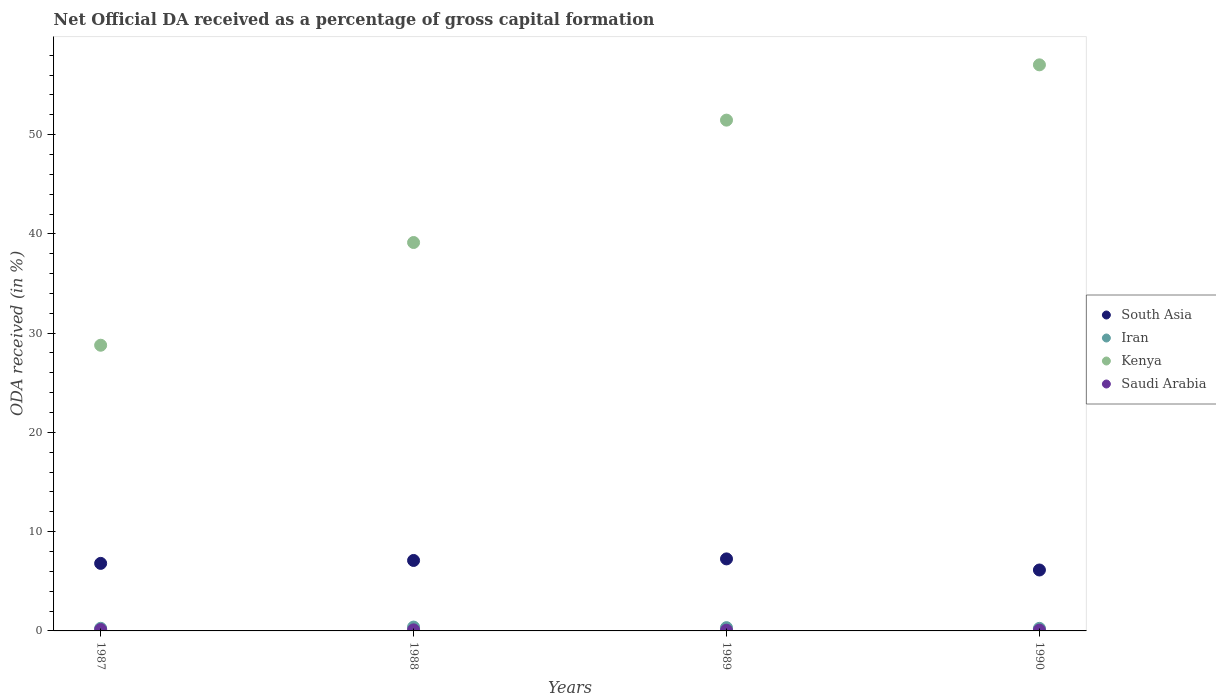How many different coloured dotlines are there?
Offer a very short reply. 4. What is the net ODA received in South Asia in 1988?
Your response must be concise. 7.1. Across all years, what is the maximum net ODA received in Saudi Arabia?
Your answer should be compact. 0.14. Across all years, what is the minimum net ODA received in Saudi Arabia?
Ensure brevity in your answer.  0.07. In which year was the net ODA received in Saudi Arabia minimum?
Your answer should be very brief. 1989. What is the total net ODA received in Kenya in the graph?
Offer a terse response. 176.4. What is the difference between the net ODA received in Saudi Arabia in 1989 and that in 1990?
Give a very brief answer. -0.01. What is the difference between the net ODA received in Iran in 1988 and the net ODA received in South Asia in 1987?
Your response must be concise. -6.42. What is the average net ODA received in Kenya per year?
Make the answer very short. 44.1. In the year 1989, what is the difference between the net ODA received in Iran and net ODA received in Kenya?
Offer a very short reply. -51.13. What is the ratio of the net ODA received in South Asia in 1987 to that in 1989?
Offer a terse response. 0.94. Is the difference between the net ODA received in Iran in 1988 and 1989 greater than the difference between the net ODA received in Kenya in 1988 and 1989?
Make the answer very short. Yes. What is the difference between the highest and the second highest net ODA received in Iran?
Your answer should be very brief. 0.06. What is the difference between the highest and the lowest net ODA received in Iran?
Provide a succinct answer. 0.13. Is the net ODA received in Saudi Arabia strictly greater than the net ODA received in South Asia over the years?
Give a very brief answer. No. How many dotlines are there?
Offer a very short reply. 4. How many years are there in the graph?
Make the answer very short. 4. Are the values on the major ticks of Y-axis written in scientific E-notation?
Offer a very short reply. No. Does the graph contain grids?
Provide a succinct answer. No. Where does the legend appear in the graph?
Give a very brief answer. Center right. How many legend labels are there?
Your answer should be compact. 4. How are the legend labels stacked?
Give a very brief answer. Vertical. What is the title of the graph?
Keep it short and to the point. Net Official DA received as a percentage of gross capital formation. Does "Tonga" appear as one of the legend labels in the graph?
Ensure brevity in your answer.  No. What is the label or title of the X-axis?
Provide a short and direct response. Years. What is the label or title of the Y-axis?
Give a very brief answer. ODA received (in %). What is the ODA received (in %) in South Asia in 1987?
Offer a very short reply. 6.8. What is the ODA received (in %) in Iran in 1987?
Your answer should be very brief. 0.26. What is the ODA received (in %) in Kenya in 1987?
Provide a short and direct response. 28.78. What is the ODA received (in %) of Saudi Arabia in 1987?
Your response must be concise. 0.14. What is the ODA received (in %) in South Asia in 1988?
Your answer should be compact. 7.1. What is the ODA received (in %) in Iran in 1988?
Your answer should be very brief. 0.39. What is the ODA received (in %) of Kenya in 1988?
Offer a very short reply. 39.13. What is the ODA received (in %) in Saudi Arabia in 1988?
Offer a very short reply. 0.11. What is the ODA received (in %) in South Asia in 1989?
Your answer should be very brief. 7.26. What is the ODA received (in %) of Iran in 1989?
Give a very brief answer. 0.33. What is the ODA received (in %) in Kenya in 1989?
Make the answer very short. 51.46. What is the ODA received (in %) in Saudi Arabia in 1989?
Your answer should be very brief. 0.07. What is the ODA received (in %) in South Asia in 1990?
Give a very brief answer. 6.14. What is the ODA received (in %) in Iran in 1990?
Provide a succinct answer. 0.26. What is the ODA received (in %) of Kenya in 1990?
Provide a succinct answer. 57.03. What is the ODA received (in %) in Saudi Arabia in 1990?
Make the answer very short. 0.08. Across all years, what is the maximum ODA received (in %) of South Asia?
Your answer should be compact. 7.26. Across all years, what is the maximum ODA received (in %) in Iran?
Your answer should be compact. 0.39. Across all years, what is the maximum ODA received (in %) of Kenya?
Offer a terse response. 57.03. Across all years, what is the maximum ODA received (in %) in Saudi Arabia?
Your answer should be very brief. 0.14. Across all years, what is the minimum ODA received (in %) of South Asia?
Make the answer very short. 6.14. Across all years, what is the minimum ODA received (in %) in Iran?
Offer a very short reply. 0.26. Across all years, what is the minimum ODA received (in %) in Kenya?
Give a very brief answer. 28.78. Across all years, what is the minimum ODA received (in %) of Saudi Arabia?
Give a very brief answer. 0.07. What is the total ODA received (in %) of South Asia in the graph?
Offer a terse response. 27.3. What is the total ODA received (in %) in Iran in the graph?
Make the answer very short. 1.24. What is the total ODA received (in %) in Kenya in the graph?
Your response must be concise. 176.4. What is the total ODA received (in %) of Saudi Arabia in the graph?
Your response must be concise. 0.4. What is the difference between the ODA received (in %) of South Asia in 1987 and that in 1988?
Your response must be concise. -0.29. What is the difference between the ODA received (in %) in Iran in 1987 and that in 1988?
Give a very brief answer. -0.12. What is the difference between the ODA received (in %) in Kenya in 1987 and that in 1988?
Offer a very short reply. -10.35. What is the difference between the ODA received (in %) of Saudi Arabia in 1987 and that in 1988?
Ensure brevity in your answer.  0.03. What is the difference between the ODA received (in %) of South Asia in 1987 and that in 1989?
Your answer should be very brief. -0.45. What is the difference between the ODA received (in %) of Iran in 1987 and that in 1989?
Provide a succinct answer. -0.07. What is the difference between the ODA received (in %) of Kenya in 1987 and that in 1989?
Provide a succinct answer. -22.68. What is the difference between the ODA received (in %) of Saudi Arabia in 1987 and that in 1989?
Offer a terse response. 0.07. What is the difference between the ODA received (in %) of South Asia in 1987 and that in 1990?
Offer a very short reply. 0.67. What is the difference between the ODA received (in %) of Iran in 1987 and that in 1990?
Keep it short and to the point. 0.01. What is the difference between the ODA received (in %) of Kenya in 1987 and that in 1990?
Offer a very short reply. -28.25. What is the difference between the ODA received (in %) in Saudi Arabia in 1987 and that in 1990?
Provide a short and direct response. 0.06. What is the difference between the ODA received (in %) in South Asia in 1988 and that in 1989?
Provide a succinct answer. -0.16. What is the difference between the ODA received (in %) of Iran in 1988 and that in 1989?
Give a very brief answer. 0.06. What is the difference between the ODA received (in %) of Kenya in 1988 and that in 1989?
Your answer should be compact. -12.33. What is the difference between the ODA received (in %) of Saudi Arabia in 1988 and that in 1989?
Give a very brief answer. 0.03. What is the difference between the ODA received (in %) in South Asia in 1988 and that in 1990?
Provide a short and direct response. 0.96. What is the difference between the ODA received (in %) in Iran in 1988 and that in 1990?
Give a very brief answer. 0.13. What is the difference between the ODA received (in %) of Kenya in 1988 and that in 1990?
Your response must be concise. -17.9. What is the difference between the ODA received (in %) of Saudi Arabia in 1988 and that in 1990?
Your answer should be very brief. 0.02. What is the difference between the ODA received (in %) in South Asia in 1989 and that in 1990?
Make the answer very short. 1.12. What is the difference between the ODA received (in %) in Iran in 1989 and that in 1990?
Provide a short and direct response. 0.07. What is the difference between the ODA received (in %) in Kenya in 1989 and that in 1990?
Ensure brevity in your answer.  -5.57. What is the difference between the ODA received (in %) of Saudi Arabia in 1989 and that in 1990?
Provide a short and direct response. -0.01. What is the difference between the ODA received (in %) of South Asia in 1987 and the ODA received (in %) of Iran in 1988?
Your answer should be compact. 6.42. What is the difference between the ODA received (in %) of South Asia in 1987 and the ODA received (in %) of Kenya in 1988?
Give a very brief answer. -32.33. What is the difference between the ODA received (in %) in South Asia in 1987 and the ODA received (in %) in Saudi Arabia in 1988?
Provide a short and direct response. 6.7. What is the difference between the ODA received (in %) in Iran in 1987 and the ODA received (in %) in Kenya in 1988?
Give a very brief answer. -38.87. What is the difference between the ODA received (in %) of Iran in 1987 and the ODA received (in %) of Saudi Arabia in 1988?
Ensure brevity in your answer.  0.16. What is the difference between the ODA received (in %) in Kenya in 1987 and the ODA received (in %) in Saudi Arabia in 1988?
Give a very brief answer. 28.67. What is the difference between the ODA received (in %) in South Asia in 1987 and the ODA received (in %) in Iran in 1989?
Keep it short and to the point. 6.47. What is the difference between the ODA received (in %) of South Asia in 1987 and the ODA received (in %) of Kenya in 1989?
Your response must be concise. -44.65. What is the difference between the ODA received (in %) of South Asia in 1987 and the ODA received (in %) of Saudi Arabia in 1989?
Your answer should be very brief. 6.73. What is the difference between the ODA received (in %) in Iran in 1987 and the ODA received (in %) in Kenya in 1989?
Give a very brief answer. -51.19. What is the difference between the ODA received (in %) of Iran in 1987 and the ODA received (in %) of Saudi Arabia in 1989?
Provide a succinct answer. 0.19. What is the difference between the ODA received (in %) in Kenya in 1987 and the ODA received (in %) in Saudi Arabia in 1989?
Offer a very short reply. 28.71. What is the difference between the ODA received (in %) of South Asia in 1987 and the ODA received (in %) of Iran in 1990?
Provide a succinct answer. 6.55. What is the difference between the ODA received (in %) in South Asia in 1987 and the ODA received (in %) in Kenya in 1990?
Make the answer very short. -50.22. What is the difference between the ODA received (in %) of South Asia in 1987 and the ODA received (in %) of Saudi Arabia in 1990?
Offer a terse response. 6.72. What is the difference between the ODA received (in %) of Iran in 1987 and the ODA received (in %) of Kenya in 1990?
Your response must be concise. -56.76. What is the difference between the ODA received (in %) in Iran in 1987 and the ODA received (in %) in Saudi Arabia in 1990?
Your answer should be compact. 0.18. What is the difference between the ODA received (in %) in Kenya in 1987 and the ODA received (in %) in Saudi Arabia in 1990?
Give a very brief answer. 28.7. What is the difference between the ODA received (in %) in South Asia in 1988 and the ODA received (in %) in Iran in 1989?
Provide a short and direct response. 6.77. What is the difference between the ODA received (in %) of South Asia in 1988 and the ODA received (in %) of Kenya in 1989?
Offer a very short reply. -44.36. What is the difference between the ODA received (in %) in South Asia in 1988 and the ODA received (in %) in Saudi Arabia in 1989?
Your answer should be compact. 7.02. What is the difference between the ODA received (in %) in Iran in 1988 and the ODA received (in %) in Kenya in 1989?
Provide a short and direct response. -51.07. What is the difference between the ODA received (in %) of Iran in 1988 and the ODA received (in %) of Saudi Arabia in 1989?
Give a very brief answer. 0.31. What is the difference between the ODA received (in %) of Kenya in 1988 and the ODA received (in %) of Saudi Arabia in 1989?
Your response must be concise. 39.06. What is the difference between the ODA received (in %) in South Asia in 1988 and the ODA received (in %) in Iran in 1990?
Ensure brevity in your answer.  6.84. What is the difference between the ODA received (in %) in South Asia in 1988 and the ODA received (in %) in Kenya in 1990?
Ensure brevity in your answer.  -49.93. What is the difference between the ODA received (in %) in South Asia in 1988 and the ODA received (in %) in Saudi Arabia in 1990?
Your response must be concise. 7.01. What is the difference between the ODA received (in %) of Iran in 1988 and the ODA received (in %) of Kenya in 1990?
Ensure brevity in your answer.  -56.64. What is the difference between the ODA received (in %) in Iran in 1988 and the ODA received (in %) in Saudi Arabia in 1990?
Your answer should be very brief. 0.3. What is the difference between the ODA received (in %) in Kenya in 1988 and the ODA received (in %) in Saudi Arabia in 1990?
Provide a short and direct response. 39.05. What is the difference between the ODA received (in %) in South Asia in 1989 and the ODA received (in %) in Iran in 1990?
Provide a short and direct response. 7. What is the difference between the ODA received (in %) in South Asia in 1989 and the ODA received (in %) in Kenya in 1990?
Your answer should be very brief. -49.77. What is the difference between the ODA received (in %) of South Asia in 1989 and the ODA received (in %) of Saudi Arabia in 1990?
Give a very brief answer. 7.17. What is the difference between the ODA received (in %) in Iran in 1989 and the ODA received (in %) in Kenya in 1990?
Provide a succinct answer. -56.7. What is the difference between the ODA received (in %) in Iran in 1989 and the ODA received (in %) in Saudi Arabia in 1990?
Your answer should be very brief. 0.25. What is the difference between the ODA received (in %) of Kenya in 1989 and the ODA received (in %) of Saudi Arabia in 1990?
Your answer should be compact. 51.37. What is the average ODA received (in %) in South Asia per year?
Your response must be concise. 6.82. What is the average ODA received (in %) in Iran per year?
Keep it short and to the point. 0.31. What is the average ODA received (in %) in Kenya per year?
Give a very brief answer. 44.1. What is the average ODA received (in %) in Saudi Arabia per year?
Make the answer very short. 0.1. In the year 1987, what is the difference between the ODA received (in %) of South Asia and ODA received (in %) of Iran?
Make the answer very short. 6.54. In the year 1987, what is the difference between the ODA received (in %) of South Asia and ODA received (in %) of Kenya?
Offer a very short reply. -21.98. In the year 1987, what is the difference between the ODA received (in %) in South Asia and ODA received (in %) in Saudi Arabia?
Give a very brief answer. 6.66. In the year 1987, what is the difference between the ODA received (in %) in Iran and ODA received (in %) in Kenya?
Provide a succinct answer. -28.52. In the year 1987, what is the difference between the ODA received (in %) in Iran and ODA received (in %) in Saudi Arabia?
Make the answer very short. 0.12. In the year 1987, what is the difference between the ODA received (in %) in Kenya and ODA received (in %) in Saudi Arabia?
Your answer should be compact. 28.64. In the year 1988, what is the difference between the ODA received (in %) in South Asia and ODA received (in %) in Iran?
Keep it short and to the point. 6.71. In the year 1988, what is the difference between the ODA received (in %) of South Asia and ODA received (in %) of Kenya?
Provide a short and direct response. -32.03. In the year 1988, what is the difference between the ODA received (in %) in South Asia and ODA received (in %) in Saudi Arabia?
Your response must be concise. 6.99. In the year 1988, what is the difference between the ODA received (in %) in Iran and ODA received (in %) in Kenya?
Ensure brevity in your answer.  -38.74. In the year 1988, what is the difference between the ODA received (in %) of Iran and ODA received (in %) of Saudi Arabia?
Make the answer very short. 0.28. In the year 1988, what is the difference between the ODA received (in %) in Kenya and ODA received (in %) in Saudi Arabia?
Your answer should be very brief. 39.02. In the year 1989, what is the difference between the ODA received (in %) of South Asia and ODA received (in %) of Iran?
Provide a succinct answer. 6.93. In the year 1989, what is the difference between the ODA received (in %) of South Asia and ODA received (in %) of Kenya?
Make the answer very short. -44.2. In the year 1989, what is the difference between the ODA received (in %) of South Asia and ODA received (in %) of Saudi Arabia?
Provide a succinct answer. 7.18. In the year 1989, what is the difference between the ODA received (in %) of Iran and ODA received (in %) of Kenya?
Provide a short and direct response. -51.13. In the year 1989, what is the difference between the ODA received (in %) of Iran and ODA received (in %) of Saudi Arabia?
Provide a succinct answer. 0.26. In the year 1989, what is the difference between the ODA received (in %) of Kenya and ODA received (in %) of Saudi Arabia?
Keep it short and to the point. 51.38. In the year 1990, what is the difference between the ODA received (in %) of South Asia and ODA received (in %) of Iran?
Your answer should be compact. 5.88. In the year 1990, what is the difference between the ODA received (in %) in South Asia and ODA received (in %) in Kenya?
Give a very brief answer. -50.89. In the year 1990, what is the difference between the ODA received (in %) in South Asia and ODA received (in %) in Saudi Arabia?
Offer a very short reply. 6.05. In the year 1990, what is the difference between the ODA received (in %) in Iran and ODA received (in %) in Kenya?
Provide a succinct answer. -56.77. In the year 1990, what is the difference between the ODA received (in %) of Iran and ODA received (in %) of Saudi Arabia?
Ensure brevity in your answer.  0.17. In the year 1990, what is the difference between the ODA received (in %) in Kenya and ODA received (in %) in Saudi Arabia?
Your answer should be very brief. 56.94. What is the ratio of the ODA received (in %) in South Asia in 1987 to that in 1988?
Your answer should be very brief. 0.96. What is the ratio of the ODA received (in %) of Iran in 1987 to that in 1988?
Offer a terse response. 0.68. What is the ratio of the ODA received (in %) in Kenya in 1987 to that in 1988?
Keep it short and to the point. 0.74. What is the ratio of the ODA received (in %) of Saudi Arabia in 1987 to that in 1988?
Make the answer very short. 1.3. What is the ratio of the ODA received (in %) of South Asia in 1987 to that in 1989?
Your response must be concise. 0.94. What is the ratio of the ODA received (in %) of Iran in 1987 to that in 1989?
Your answer should be compact. 0.8. What is the ratio of the ODA received (in %) in Kenya in 1987 to that in 1989?
Provide a succinct answer. 0.56. What is the ratio of the ODA received (in %) of Saudi Arabia in 1987 to that in 1989?
Offer a terse response. 1.91. What is the ratio of the ODA received (in %) of South Asia in 1987 to that in 1990?
Make the answer very short. 1.11. What is the ratio of the ODA received (in %) in Iran in 1987 to that in 1990?
Offer a very short reply. 1.02. What is the ratio of the ODA received (in %) in Kenya in 1987 to that in 1990?
Your answer should be compact. 0.5. What is the ratio of the ODA received (in %) of Saudi Arabia in 1987 to that in 1990?
Ensure brevity in your answer.  1.69. What is the ratio of the ODA received (in %) in South Asia in 1988 to that in 1989?
Your response must be concise. 0.98. What is the ratio of the ODA received (in %) in Iran in 1988 to that in 1989?
Your answer should be very brief. 1.17. What is the ratio of the ODA received (in %) of Kenya in 1988 to that in 1989?
Provide a short and direct response. 0.76. What is the ratio of the ODA received (in %) of Saudi Arabia in 1988 to that in 1989?
Your answer should be very brief. 1.47. What is the ratio of the ODA received (in %) of South Asia in 1988 to that in 1990?
Provide a succinct answer. 1.16. What is the ratio of the ODA received (in %) of Iran in 1988 to that in 1990?
Ensure brevity in your answer.  1.49. What is the ratio of the ODA received (in %) of Kenya in 1988 to that in 1990?
Offer a terse response. 0.69. What is the ratio of the ODA received (in %) in Saudi Arabia in 1988 to that in 1990?
Ensure brevity in your answer.  1.29. What is the ratio of the ODA received (in %) in South Asia in 1989 to that in 1990?
Ensure brevity in your answer.  1.18. What is the ratio of the ODA received (in %) of Iran in 1989 to that in 1990?
Offer a very short reply. 1.27. What is the ratio of the ODA received (in %) in Kenya in 1989 to that in 1990?
Provide a short and direct response. 0.9. What is the ratio of the ODA received (in %) in Saudi Arabia in 1989 to that in 1990?
Make the answer very short. 0.88. What is the difference between the highest and the second highest ODA received (in %) of South Asia?
Keep it short and to the point. 0.16. What is the difference between the highest and the second highest ODA received (in %) of Iran?
Give a very brief answer. 0.06. What is the difference between the highest and the second highest ODA received (in %) of Kenya?
Offer a very short reply. 5.57. What is the difference between the highest and the second highest ODA received (in %) in Saudi Arabia?
Your response must be concise. 0.03. What is the difference between the highest and the lowest ODA received (in %) of South Asia?
Provide a short and direct response. 1.12. What is the difference between the highest and the lowest ODA received (in %) of Iran?
Provide a succinct answer. 0.13. What is the difference between the highest and the lowest ODA received (in %) in Kenya?
Offer a terse response. 28.25. What is the difference between the highest and the lowest ODA received (in %) in Saudi Arabia?
Keep it short and to the point. 0.07. 